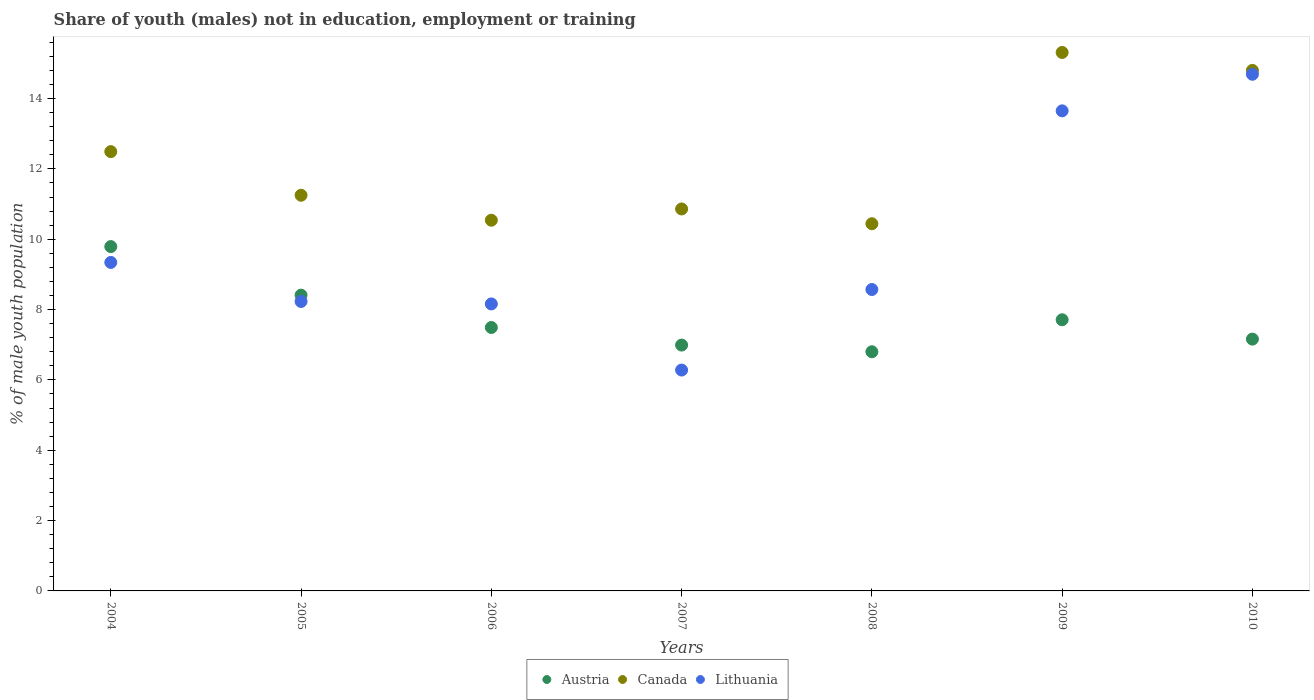How many different coloured dotlines are there?
Ensure brevity in your answer.  3. Is the number of dotlines equal to the number of legend labels?
Offer a terse response. Yes. What is the percentage of unemployed males population in in Austria in 2010?
Make the answer very short. 7.16. Across all years, what is the maximum percentage of unemployed males population in in Canada?
Your answer should be compact. 15.31. Across all years, what is the minimum percentage of unemployed males population in in Austria?
Offer a terse response. 6.8. What is the total percentage of unemployed males population in in Austria in the graph?
Your answer should be compact. 54.35. What is the difference between the percentage of unemployed males population in in Lithuania in 2006 and that in 2008?
Keep it short and to the point. -0.41. What is the difference between the percentage of unemployed males population in in Canada in 2004 and the percentage of unemployed males population in in Austria in 2010?
Your answer should be very brief. 5.33. What is the average percentage of unemployed males population in in Austria per year?
Your answer should be very brief. 7.76. In the year 2008, what is the difference between the percentage of unemployed males population in in Canada and percentage of unemployed males population in in Austria?
Your answer should be very brief. 3.64. What is the ratio of the percentage of unemployed males population in in Canada in 2004 to that in 2009?
Keep it short and to the point. 0.82. Is the difference between the percentage of unemployed males population in in Canada in 2008 and 2010 greater than the difference between the percentage of unemployed males population in in Austria in 2008 and 2010?
Your answer should be compact. No. What is the difference between the highest and the second highest percentage of unemployed males population in in Canada?
Ensure brevity in your answer.  0.51. What is the difference between the highest and the lowest percentage of unemployed males population in in Canada?
Make the answer very short. 4.87. Is it the case that in every year, the sum of the percentage of unemployed males population in in Austria and percentage of unemployed males population in in Lithuania  is greater than the percentage of unemployed males population in in Canada?
Your answer should be compact. Yes. How many dotlines are there?
Give a very brief answer. 3. How many years are there in the graph?
Make the answer very short. 7. Does the graph contain grids?
Provide a short and direct response. No. How are the legend labels stacked?
Ensure brevity in your answer.  Horizontal. What is the title of the graph?
Your response must be concise. Share of youth (males) not in education, employment or training. Does "World" appear as one of the legend labels in the graph?
Make the answer very short. No. What is the label or title of the Y-axis?
Your answer should be compact. % of male youth population. What is the % of male youth population in Austria in 2004?
Provide a succinct answer. 9.79. What is the % of male youth population of Canada in 2004?
Ensure brevity in your answer.  12.49. What is the % of male youth population in Lithuania in 2004?
Offer a terse response. 9.34. What is the % of male youth population in Austria in 2005?
Offer a very short reply. 8.41. What is the % of male youth population of Canada in 2005?
Your response must be concise. 11.25. What is the % of male youth population in Lithuania in 2005?
Your answer should be compact. 8.23. What is the % of male youth population of Austria in 2006?
Offer a terse response. 7.49. What is the % of male youth population of Canada in 2006?
Your response must be concise. 10.54. What is the % of male youth population of Lithuania in 2006?
Offer a terse response. 8.16. What is the % of male youth population of Austria in 2007?
Provide a short and direct response. 6.99. What is the % of male youth population in Canada in 2007?
Ensure brevity in your answer.  10.86. What is the % of male youth population in Lithuania in 2007?
Offer a terse response. 6.28. What is the % of male youth population in Austria in 2008?
Your response must be concise. 6.8. What is the % of male youth population in Canada in 2008?
Ensure brevity in your answer.  10.44. What is the % of male youth population of Lithuania in 2008?
Your answer should be very brief. 8.57. What is the % of male youth population in Austria in 2009?
Provide a succinct answer. 7.71. What is the % of male youth population of Canada in 2009?
Your answer should be very brief. 15.31. What is the % of male youth population of Lithuania in 2009?
Make the answer very short. 13.65. What is the % of male youth population of Austria in 2010?
Give a very brief answer. 7.16. What is the % of male youth population of Canada in 2010?
Give a very brief answer. 14.8. What is the % of male youth population of Lithuania in 2010?
Ensure brevity in your answer.  14.69. Across all years, what is the maximum % of male youth population in Austria?
Your response must be concise. 9.79. Across all years, what is the maximum % of male youth population in Canada?
Provide a short and direct response. 15.31. Across all years, what is the maximum % of male youth population of Lithuania?
Provide a succinct answer. 14.69. Across all years, what is the minimum % of male youth population of Austria?
Ensure brevity in your answer.  6.8. Across all years, what is the minimum % of male youth population in Canada?
Provide a succinct answer. 10.44. Across all years, what is the minimum % of male youth population in Lithuania?
Your answer should be compact. 6.28. What is the total % of male youth population of Austria in the graph?
Your answer should be compact. 54.35. What is the total % of male youth population of Canada in the graph?
Give a very brief answer. 85.69. What is the total % of male youth population in Lithuania in the graph?
Keep it short and to the point. 68.92. What is the difference between the % of male youth population of Austria in 2004 and that in 2005?
Your answer should be very brief. 1.38. What is the difference between the % of male youth population of Canada in 2004 and that in 2005?
Offer a terse response. 1.24. What is the difference between the % of male youth population in Lithuania in 2004 and that in 2005?
Provide a succinct answer. 1.11. What is the difference between the % of male youth population in Canada in 2004 and that in 2006?
Your answer should be very brief. 1.95. What is the difference between the % of male youth population of Lithuania in 2004 and that in 2006?
Your answer should be very brief. 1.18. What is the difference between the % of male youth population in Canada in 2004 and that in 2007?
Your answer should be very brief. 1.63. What is the difference between the % of male youth population in Lithuania in 2004 and that in 2007?
Give a very brief answer. 3.06. What is the difference between the % of male youth population in Austria in 2004 and that in 2008?
Provide a succinct answer. 2.99. What is the difference between the % of male youth population in Canada in 2004 and that in 2008?
Give a very brief answer. 2.05. What is the difference between the % of male youth population in Lithuania in 2004 and that in 2008?
Provide a succinct answer. 0.77. What is the difference between the % of male youth population of Austria in 2004 and that in 2009?
Your answer should be very brief. 2.08. What is the difference between the % of male youth population in Canada in 2004 and that in 2009?
Your response must be concise. -2.82. What is the difference between the % of male youth population of Lithuania in 2004 and that in 2009?
Keep it short and to the point. -4.31. What is the difference between the % of male youth population in Austria in 2004 and that in 2010?
Provide a short and direct response. 2.63. What is the difference between the % of male youth population of Canada in 2004 and that in 2010?
Provide a short and direct response. -2.31. What is the difference between the % of male youth population in Lithuania in 2004 and that in 2010?
Provide a succinct answer. -5.35. What is the difference between the % of male youth population of Austria in 2005 and that in 2006?
Make the answer very short. 0.92. What is the difference between the % of male youth population of Canada in 2005 and that in 2006?
Offer a very short reply. 0.71. What is the difference between the % of male youth population in Lithuania in 2005 and that in 2006?
Your answer should be compact. 0.07. What is the difference between the % of male youth population of Austria in 2005 and that in 2007?
Keep it short and to the point. 1.42. What is the difference between the % of male youth population of Canada in 2005 and that in 2007?
Your answer should be very brief. 0.39. What is the difference between the % of male youth population in Lithuania in 2005 and that in 2007?
Offer a terse response. 1.95. What is the difference between the % of male youth population of Austria in 2005 and that in 2008?
Your response must be concise. 1.61. What is the difference between the % of male youth population of Canada in 2005 and that in 2008?
Offer a terse response. 0.81. What is the difference between the % of male youth population of Lithuania in 2005 and that in 2008?
Offer a terse response. -0.34. What is the difference between the % of male youth population in Austria in 2005 and that in 2009?
Your answer should be very brief. 0.7. What is the difference between the % of male youth population of Canada in 2005 and that in 2009?
Your answer should be compact. -4.06. What is the difference between the % of male youth population in Lithuania in 2005 and that in 2009?
Offer a terse response. -5.42. What is the difference between the % of male youth population of Canada in 2005 and that in 2010?
Offer a terse response. -3.55. What is the difference between the % of male youth population of Lithuania in 2005 and that in 2010?
Provide a succinct answer. -6.46. What is the difference between the % of male youth population in Canada in 2006 and that in 2007?
Keep it short and to the point. -0.32. What is the difference between the % of male youth population in Lithuania in 2006 and that in 2007?
Your answer should be compact. 1.88. What is the difference between the % of male youth population of Austria in 2006 and that in 2008?
Your response must be concise. 0.69. What is the difference between the % of male youth population in Canada in 2006 and that in 2008?
Your answer should be compact. 0.1. What is the difference between the % of male youth population in Lithuania in 2006 and that in 2008?
Provide a succinct answer. -0.41. What is the difference between the % of male youth population of Austria in 2006 and that in 2009?
Your response must be concise. -0.22. What is the difference between the % of male youth population of Canada in 2006 and that in 2009?
Your answer should be compact. -4.77. What is the difference between the % of male youth population in Lithuania in 2006 and that in 2009?
Make the answer very short. -5.49. What is the difference between the % of male youth population of Austria in 2006 and that in 2010?
Make the answer very short. 0.33. What is the difference between the % of male youth population in Canada in 2006 and that in 2010?
Ensure brevity in your answer.  -4.26. What is the difference between the % of male youth population in Lithuania in 2006 and that in 2010?
Offer a terse response. -6.53. What is the difference between the % of male youth population in Austria in 2007 and that in 2008?
Your answer should be compact. 0.19. What is the difference between the % of male youth population of Canada in 2007 and that in 2008?
Provide a succinct answer. 0.42. What is the difference between the % of male youth population of Lithuania in 2007 and that in 2008?
Make the answer very short. -2.29. What is the difference between the % of male youth population of Austria in 2007 and that in 2009?
Provide a short and direct response. -0.72. What is the difference between the % of male youth population in Canada in 2007 and that in 2009?
Your response must be concise. -4.45. What is the difference between the % of male youth population in Lithuania in 2007 and that in 2009?
Make the answer very short. -7.37. What is the difference between the % of male youth population in Austria in 2007 and that in 2010?
Make the answer very short. -0.17. What is the difference between the % of male youth population in Canada in 2007 and that in 2010?
Offer a terse response. -3.94. What is the difference between the % of male youth population of Lithuania in 2007 and that in 2010?
Your answer should be very brief. -8.41. What is the difference between the % of male youth population of Austria in 2008 and that in 2009?
Provide a succinct answer. -0.91. What is the difference between the % of male youth population of Canada in 2008 and that in 2009?
Ensure brevity in your answer.  -4.87. What is the difference between the % of male youth population in Lithuania in 2008 and that in 2009?
Offer a very short reply. -5.08. What is the difference between the % of male youth population in Austria in 2008 and that in 2010?
Ensure brevity in your answer.  -0.36. What is the difference between the % of male youth population of Canada in 2008 and that in 2010?
Your response must be concise. -4.36. What is the difference between the % of male youth population in Lithuania in 2008 and that in 2010?
Provide a succinct answer. -6.12. What is the difference between the % of male youth population in Austria in 2009 and that in 2010?
Offer a very short reply. 0.55. What is the difference between the % of male youth population in Canada in 2009 and that in 2010?
Offer a very short reply. 0.51. What is the difference between the % of male youth population of Lithuania in 2009 and that in 2010?
Keep it short and to the point. -1.04. What is the difference between the % of male youth population of Austria in 2004 and the % of male youth population of Canada in 2005?
Make the answer very short. -1.46. What is the difference between the % of male youth population in Austria in 2004 and the % of male youth population in Lithuania in 2005?
Provide a short and direct response. 1.56. What is the difference between the % of male youth population in Canada in 2004 and the % of male youth population in Lithuania in 2005?
Provide a short and direct response. 4.26. What is the difference between the % of male youth population in Austria in 2004 and the % of male youth population in Canada in 2006?
Keep it short and to the point. -0.75. What is the difference between the % of male youth population in Austria in 2004 and the % of male youth population in Lithuania in 2006?
Keep it short and to the point. 1.63. What is the difference between the % of male youth population of Canada in 2004 and the % of male youth population of Lithuania in 2006?
Keep it short and to the point. 4.33. What is the difference between the % of male youth population of Austria in 2004 and the % of male youth population of Canada in 2007?
Keep it short and to the point. -1.07. What is the difference between the % of male youth population of Austria in 2004 and the % of male youth population of Lithuania in 2007?
Your answer should be very brief. 3.51. What is the difference between the % of male youth population of Canada in 2004 and the % of male youth population of Lithuania in 2007?
Offer a terse response. 6.21. What is the difference between the % of male youth population in Austria in 2004 and the % of male youth population in Canada in 2008?
Give a very brief answer. -0.65. What is the difference between the % of male youth population of Austria in 2004 and the % of male youth population of Lithuania in 2008?
Provide a short and direct response. 1.22. What is the difference between the % of male youth population of Canada in 2004 and the % of male youth population of Lithuania in 2008?
Give a very brief answer. 3.92. What is the difference between the % of male youth population in Austria in 2004 and the % of male youth population in Canada in 2009?
Provide a succinct answer. -5.52. What is the difference between the % of male youth population of Austria in 2004 and the % of male youth population of Lithuania in 2009?
Your response must be concise. -3.86. What is the difference between the % of male youth population of Canada in 2004 and the % of male youth population of Lithuania in 2009?
Offer a very short reply. -1.16. What is the difference between the % of male youth population of Austria in 2004 and the % of male youth population of Canada in 2010?
Provide a succinct answer. -5.01. What is the difference between the % of male youth population of Austria in 2004 and the % of male youth population of Lithuania in 2010?
Give a very brief answer. -4.9. What is the difference between the % of male youth population of Canada in 2004 and the % of male youth population of Lithuania in 2010?
Provide a succinct answer. -2.2. What is the difference between the % of male youth population of Austria in 2005 and the % of male youth population of Canada in 2006?
Your response must be concise. -2.13. What is the difference between the % of male youth population of Austria in 2005 and the % of male youth population of Lithuania in 2006?
Provide a succinct answer. 0.25. What is the difference between the % of male youth population in Canada in 2005 and the % of male youth population in Lithuania in 2006?
Keep it short and to the point. 3.09. What is the difference between the % of male youth population of Austria in 2005 and the % of male youth population of Canada in 2007?
Offer a very short reply. -2.45. What is the difference between the % of male youth population in Austria in 2005 and the % of male youth population in Lithuania in 2007?
Your answer should be very brief. 2.13. What is the difference between the % of male youth population in Canada in 2005 and the % of male youth population in Lithuania in 2007?
Your response must be concise. 4.97. What is the difference between the % of male youth population in Austria in 2005 and the % of male youth population in Canada in 2008?
Give a very brief answer. -2.03. What is the difference between the % of male youth population in Austria in 2005 and the % of male youth population in Lithuania in 2008?
Make the answer very short. -0.16. What is the difference between the % of male youth population in Canada in 2005 and the % of male youth population in Lithuania in 2008?
Keep it short and to the point. 2.68. What is the difference between the % of male youth population of Austria in 2005 and the % of male youth population of Canada in 2009?
Give a very brief answer. -6.9. What is the difference between the % of male youth population in Austria in 2005 and the % of male youth population in Lithuania in 2009?
Give a very brief answer. -5.24. What is the difference between the % of male youth population in Austria in 2005 and the % of male youth population in Canada in 2010?
Offer a very short reply. -6.39. What is the difference between the % of male youth population in Austria in 2005 and the % of male youth population in Lithuania in 2010?
Ensure brevity in your answer.  -6.28. What is the difference between the % of male youth population in Canada in 2005 and the % of male youth population in Lithuania in 2010?
Your answer should be compact. -3.44. What is the difference between the % of male youth population of Austria in 2006 and the % of male youth population of Canada in 2007?
Your answer should be very brief. -3.37. What is the difference between the % of male youth population of Austria in 2006 and the % of male youth population of Lithuania in 2007?
Provide a succinct answer. 1.21. What is the difference between the % of male youth population in Canada in 2006 and the % of male youth population in Lithuania in 2007?
Keep it short and to the point. 4.26. What is the difference between the % of male youth population of Austria in 2006 and the % of male youth population of Canada in 2008?
Offer a terse response. -2.95. What is the difference between the % of male youth population in Austria in 2006 and the % of male youth population in Lithuania in 2008?
Give a very brief answer. -1.08. What is the difference between the % of male youth population of Canada in 2006 and the % of male youth population of Lithuania in 2008?
Give a very brief answer. 1.97. What is the difference between the % of male youth population in Austria in 2006 and the % of male youth population in Canada in 2009?
Give a very brief answer. -7.82. What is the difference between the % of male youth population in Austria in 2006 and the % of male youth population in Lithuania in 2009?
Ensure brevity in your answer.  -6.16. What is the difference between the % of male youth population in Canada in 2006 and the % of male youth population in Lithuania in 2009?
Provide a succinct answer. -3.11. What is the difference between the % of male youth population of Austria in 2006 and the % of male youth population of Canada in 2010?
Keep it short and to the point. -7.31. What is the difference between the % of male youth population in Canada in 2006 and the % of male youth population in Lithuania in 2010?
Offer a terse response. -4.15. What is the difference between the % of male youth population in Austria in 2007 and the % of male youth population in Canada in 2008?
Make the answer very short. -3.45. What is the difference between the % of male youth population in Austria in 2007 and the % of male youth population in Lithuania in 2008?
Provide a short and direct response. -1.58. What is the difference between the % of male youth population in Canada in 2007 and the % of male youth population in Lithuania in 2008?
Provide a short and direct response. 2.29. What is the difference between the % of male youth population of Austria in 2007 and the % of male youth population of Canada in 2009?
Provide a short and direct response. -8.32. What is the difference between the % of male youth population of Austria in 2007 and the % of male youth population of Lithuania in 2009?
Provide a short and direct response. -6.66. What is the difference between the % of male youth population of Canada in 2007 and the % of male youth population of Lithuania in 2009?
Make the answer very short. -2.79. What is the difference between the % of male youth population in Austria in 2007 and the % of male youth population in Canada in 2010?
Provide a succinct answer. -7.81. What is the difference between the % of male youth population of Austria in 2007 and the % of male youth population of Lithuania in 2010?
Provide a short and direct response. -7.7. What is the difference between the % of male youth population in Canada in 2007 and the % of male youth population in Lithuania in 2010?
Provide a succinct answer. -3.83. What is the difference between the % of male youth population in Austria in 2008 and the % of male youth population in Canada in 2009?
Your answer should be very brief. -8.51. What is the difference between the % of male youth population of Austria in 2008 and the % of male youth population of Lithuania in 2009?
Your response must be concise. -6.85. What is the difference between the % of male youth population of Canada in 2008 and the % of male youth population of Lithuania in 2009?
Make the answer very short. -3.21. What is the difference between the % of male youth population of Austria in 2008 and the % of male youth population of Lithuania in 2010?
Make the answer very short. -7.89. What is the difference between the % of male youth population of Canada in 2008 and the % of male youth population of Lithuania in 2010?
Your answer should be very brief. -4.25. What is the difference between the % of male youth population of Austria in 2009 and the % of male youth population of Canada in 2010?
Offer a very short reply. -7.09. What is the difference between the % of male youth population of Austria in 2009 and the % of male youth population of Lithuania in 2010?
Your answer should be compact. -6.98. What is the difference between the % of male youth population in Canada in 2009 and the % of male youth population in Lithuania in 2010?
Make the answer very short. 0.62. What is the average % of male youth population in Austria per year?
Provide a short and direct response. 7.76. What is the average % of male youth population in Canada per year?
Provide a succinct answer. 12.24. What is the average % of male youth population of Lithuania per year?
Your answer should be very brief. 9.85. In the year 2004, what is the difference between the % of male youth population in Austria and % of male youth population in Lithuania?
Your answer should be very brief. 0.45. In the year 2004, what is the difference between the % of male youth population in Canada and % of male youth population in Lithuania?
Provide a succinct answer. 3.15. In the year 2005, what is the difference between the % of male youth population in Austria and % of male youth population in Canada?
Your response must be concise. -2.84. In the year 2005, what is the difference between the % of male youth population of Austria and % of male youth population of Lithuania?
Ensure brevity in your answer.  0.18. In the year 2005, what is the difference between the % of male youth population in Canada and % of male youth population in Lithuania?
Your answer should be compact. 3.02. In the year 2006, what is the difference between the % of male youth population in Austria and % of male youth population in Canada?
Keep it short and to the point. -3.05. In the year 2006, what is the difference between the % of male youth population in Austria and % of male youth population in Lithuania?
Provide a short and direct response. -0.67. In the year 2006, what is the difference between the % of male youth population of Canada and % of male youth population of Lithuania?
Ensure brevity in your answer.  2.38. In the year 2007, what is the difference between the % of male youth population in Austria and % of male youth population in Canada?
Provide a short and direct response. -3.87. In the year 2007, what is the difference between the % of male youth population of Austria and % of male youth population of Lithuania?
Ensure brevity in your answer.  0.71. In the year 2007, what is the difference between the % of male youth population in Canada and % of male youth population in Lithuania?
Keep it short and to the point. 4.58. In the year 2008, what is the difference between the % of male youth population of Austria and % of male youth population of Canada?
Make the answer very short. -3.64. In the year 2008, what is the difference between the % of male youth population of Austria and % of male youth population of Lithuania?
Your answer should be compact. -1.77. In the year 2008, what is the difference between the % of male youth population in Canada and % of male youth population in Lithuania?
Your response must be concise. 1.87. In the year 2009, what is the difference between the % of male youth population in Austria and % of male youth population in Canada?
Your answer should be very brief. -7.6. In the year 2009, what is the difference between the % of male youth population in Austria and % of male youth population in Lithuania?
Offer a very short reply. -5.94. In the year 2009, what is the difference between the % of male youth population in Canada and % of male youth population in Lithuania?
Provide a succinct answer. 1.66. In the year 2010, what is the difference between the % of male youth population in Austria and % of male youth population in Canada?
Keep it short and to the point. -7.64. In the year 2010, what is the difference between the % of male youth population in Austria and % of male youth population in Lithuania?
Your answer should be compact. -7.53. In the year 2010, what is the difference between the % of male youth population of Canada and % of male youth population of Lithuania?
Ensure brevity in your answer.  0.11. What is the ratio of the % of male youth population of Austria in 2004 to that in 2005?
Provide a succinct answer. 1.16. What is the ratio of the % of male youth population of Canada in 2004 to that in 2005?
Offer a terse response. 1.11. What is the ratio of the % of male youth population of Lithuania in 2004 to that in 2005?
Give a very brief answer. 1.13. What is the ratio of the % of male youth population in Austria in 2004 to that in 2006?
Offer a very short reply. 1.31. What is the ratio of the % of male youth population of Canada in 2004 to that in 2006?
Your response must be concise. 1.19. What is the ratio of the % of male youth population in Lithuania in 2004 to that in 2006?
Ensure brevity in your answer.  1.14. What is the ratio of the % of male youth population of Austria in 2004 to that in 2007?
Make the answer very short. 1.4. What is the ratio of the % of male youth population of Canada in 2004 to that in 2007?
Provide a succinct answer. 1.15. What is the ratio of the % of male youth population of Lithuania in 2004 to that in 2007?
Offer a terse response. 1.49. What is the ratio of the % of male youth population in Austria in 2004 to that in 2008?
Your answer should be compact. 1.44. What is the ratio of the % of male youth population in Canada in 2004 to that in 2008?
Your answer should be very brief. 1.2. What is the ratio of the % of male youth population in Lithuania in 2004 to that in 2008?
Provide a succinct answer. 1.09. What is the ratio of the % of male youth population in Austria in 2004 to that in 2009?
Ensure brevity in your answer.  1.27. What is the ratio of the % of male youth population in Canada in 2004 to that in 2009?
Keep it short and to the point. 0.82. What is the ratio of the % of male youth population in Lithuania in 2004 to that in 2009?
Keep it short and to the point. 0.68. What is the ratio of the % of male youth population in Austria in 2004 to that in 2010?
Offer a very short reply. 1.37. What is the ratio of the % of male youth population in Canada in 2004 to that in 2010?
Give a very brief answer. 0.84. What is the ratio of the % of male youth population of Lithuania in 2004 to that in 2010?
Provide a short and direct response. 0.64. What is the ratio of the % of male youth population in Austria in 2005 to that in 2006?
Offer a terse response. 1.12. What is the ratio of the % of male youth population of Canada in 2005 to that in 2006?
Make the answer very short. 1.07. What is the ratio of the % of male youth population of Lithuania in 2005 to that in 2006?
Make the answer very short. 1.01. What is the ratio of the % of male youth population of Austria in 2005 to that in 2007?
Make the answer very short. 1.2. What is the ratio of the % of male youth population of Canada in 2005 to that in 2007?
Provide a succinct answer. 1.04. What is the ratio of the % of male youth population in Lithuania in 2005 to that in 2007?
Provide a succinct answer. 1.31. What is the ratio of the % of male youth population of Austria in 2005 to that in 2008?
Make the answer very short. 1.24. What is the ratio of the % of male youth population of Canada in 2005 to that in 2008?
Give a very brief answer. 1.08. What is the ratio of the % of male youth population of Lithuania in 2005 to that in 2008?
Ensure brevity in your answer.  0.96. What is the ratio of the % of male youth population in Austria in 2005 to that in 2009?
Provide a succinct answer. 1.09. What is the ratio of the % of male youth population in Canada in 2005 to that in 2009?
Provide a succinct answer. 0.73. What is the ratio of the % of male youth population of Lithuania in 2005 to that in 2009?
Your response must be concise. 0.6. What is the ratio of the % of male youth population in Austria in 2005 to that in 2010?
Offer a very short reply. 1.17. What is the ratio of the % of male youth population of Canada in 2005 to that in 2010?
Give a very brief answer. 0.76. What is the ratio of the % of male youth population of Lithuania in 2005 to that in 2010?
Ensure brevity in your answer.  0.56. What is the ratio of the % of male youth population in Austria in 2006 to that in 2007?
Keep it short and to the point. 1.07. What is the ratio of the % of male youth population in Canada in 2006 to that in 2007?
Your answer should be very brief. 0.97. What is the ratio of the % of male youth population of Lithuania in 2006 to that in 2007?
Give a very brief answer. 1.3. What is the ratio of the % of male youth population in Austria in 2006 to that in 2008?
Provide a succinct answer. 1.1. What is the ratio of the % of male youth population of Canada in 2006 to that in 2008?
Ensure brevity in your answer.  1.01. What is the ratio of the % of male youth population in Lithuania in 2006 to that in 2008?
Provide a succinct answer. 0.95. What is the ratio of the % of male youth population in Austria in 2006 to that in 2009?
Give a very brief answer. 0.97. What is the ratio of the % of male youth population in Canada in 2006 to that in 2009?
Provide a short and direct response. 0.69. What is the ratio of the % of male youth population in Lithuania in 2006 to that in 2009?
Your answer should be very brief. 0.6. What is the ratio of the % of male youth population of Austria in 2006 to that in 2010?
Give a very brief answer. 1.05. What is the ratio of the % of male youth population of Canada in 2006 to that in 2010?
Provide a succinct answer. 0.71. What is the ratio of the % of male youth population in Lithuania in 2006 to that in 2010?
Offer a very short reply. 0.56. What is the ratio of the % of male youth population of Austria in 2007 to that in 2008?
Offer a very short reply. 1.03. What is the ratio of the % of male youth population of Canada in 2007 to that in 2008?
Give a very brief answer. 1.04. What is the ratio of the % of male youth population of Lithuania in 2007 to that in 2008?
Keep it short and to the point. 0.73. What is the ratio of the % of male youth population of Austria in 2007 to that in 2009?
Provide a succinct answer. 0.91. What is the ratio of the % of male youth population of Canada in 2007 to that in 2009?
Offer a very short reply. 0.71. What is the ratio of the % of male youth population of Lithuania in 2007 to that in 2009?
Make the answer very short. 0.46. What is the ratio of the % of male youth population of Austria in 2007 to that in 2010?
Keep it short and to the point. 0.98. What is the ratio of the % of male youth population in Canada in 2007 to that in 2010?
Your answer should be very brief. 0.73. What is the ratio of the % of male youth population in Lithuania in 2007 to that in 2010?
Make the answer very short. 0.43. What is the ratio of the % of male youth population of Austria in 2008 to that in 2009?
Provide a short and direct response. 0.88. What is the ratio of the % of male youth population in Canada in 2008 to that in 2009?
Your response must be concise. 0.68. What is the ratio of the % of male youth population of Lithuania in 2008 to that in 2009?
Make the answer very short. 0.63. What is the ratio of the % of male youth population of Austria in 2008 to that in 2010?
Offer a terse response. 0.95. What is the ratio of the % of male youth population in Canada in 2008 to that in 2010?
Give a very brief answer. 0.71. What is the ratio of the % of male youth population in Lithuania in 2008 to that in 2010?
Ensure brevity in your answer.  0.58. What is the ratio of the % of male youth population of Austria in 2009 to that in 2010?
Offer a very short reply. 1.08. What is the ratio of the % of male youth population of Canada in 2009 to that in 2010?
Provide a succinct answer. 1.03. What is the ratio of the % of male youth population in Lithuania in 2009 to that in 2010?
Give a very brief answer. 0.93. What is the difference between the highest and the second highest % of male youth population in Austria?
Provide a succinct answer. 1.38. What is the difference between the highest and the second highest % of male youth population in Canada?
Provide a succinct answer. 0.51. What is the difference between the highest and the lowest % of male youth population of Austria?
Your answer should be compact. 2.99. What is the difference between the highest and the lowest % of male youth population in Canada?
Make the answer very short. 4.87. What is the difference between the highest and the lowest % of male youth population of Lithuania?
Your answer should be very brief. 8.41. 